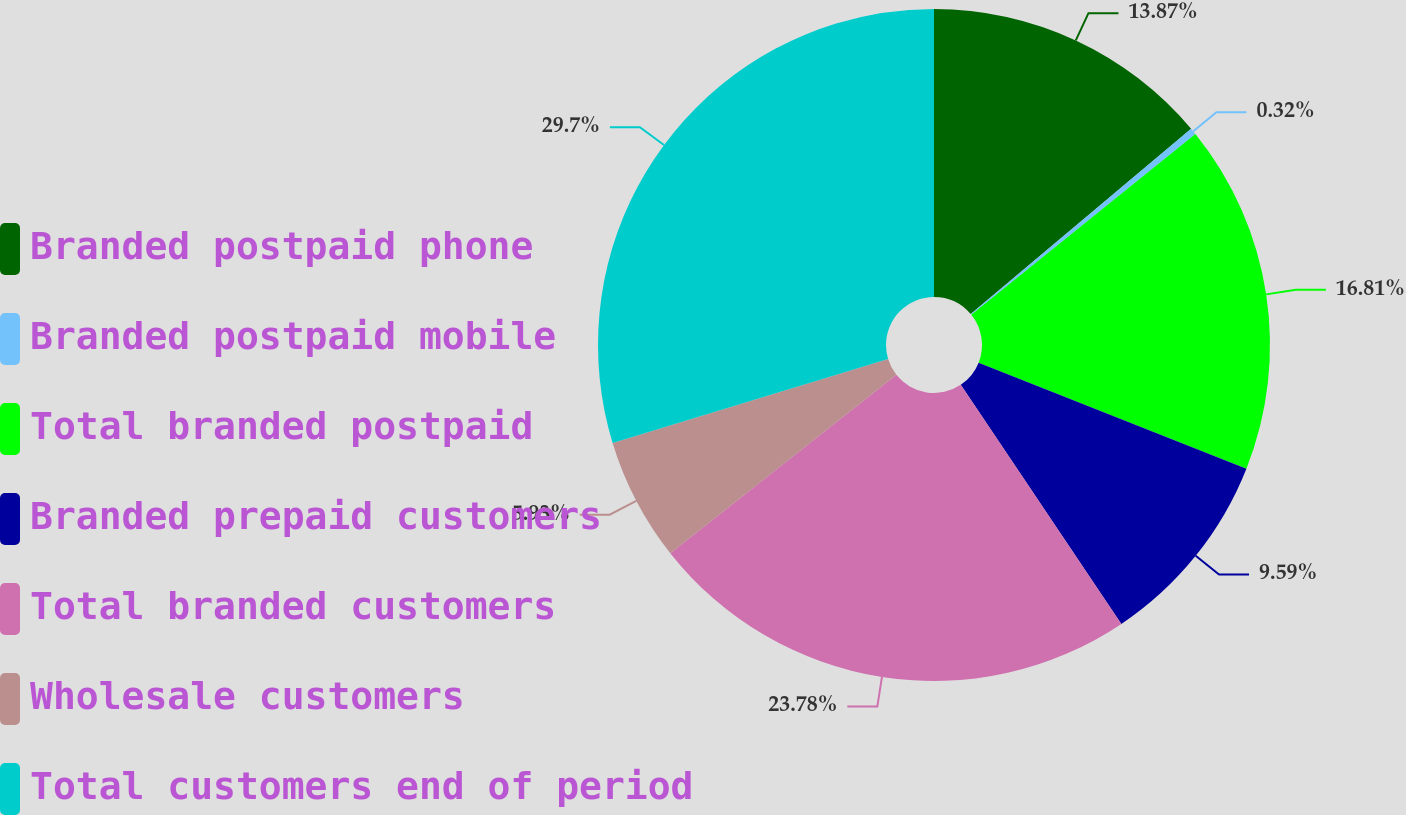Convert chart. <chart><loc_0><loc_0><loc_500><loc_500><pie_chart><fcel>Branded postpaid phone<fcel>Branded postpaid mobile<fcel>Total branded postpaid<fcel>Branded prepaid customers<fcel>Total branded customers<fcel>Wholesale customers<fcel>Total customers end of period<nl><fcel>13.87%<fcel>0.32%<fcel>16.81%<fcel>9.59%<fcel>23.78%<fcel>5.93%<fcel>29.71%<nl></chart> 